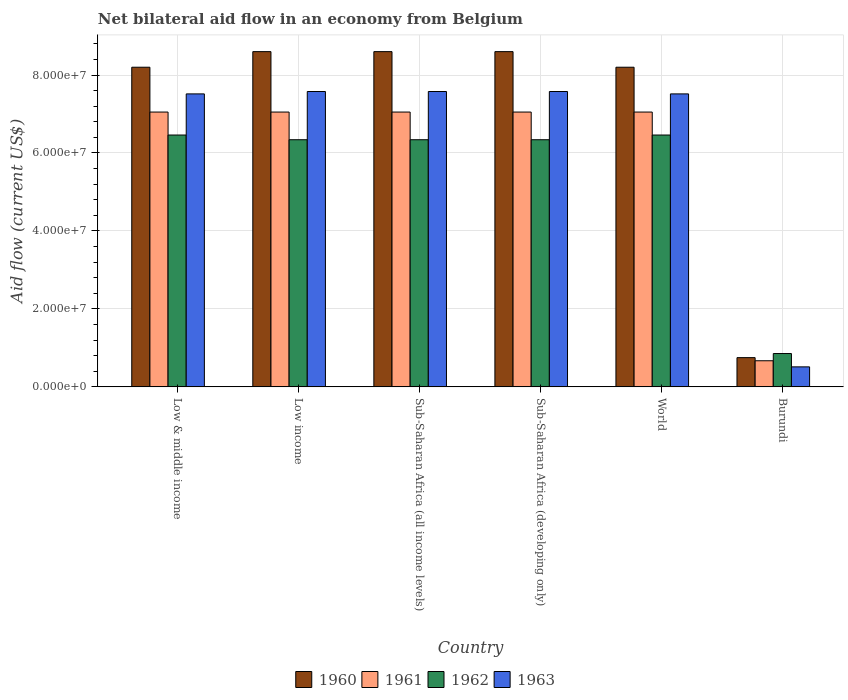How many different coloured bars are there?
Your answer should be compact. 4. Are the number of bars per tick equal to the number of legend labels?
Offer a terse response. Yes. How many bars are there on the 3rd tick from the right?
Provide a short and direct response. 4. What is the net bilateral aid flow in 1960 in Low & middle income?
Offer a terse response. 8.20e+07. Across all countries, what is the maximum net bilateral aid flow in 1963?
Your response must be concise. 7.58e+07. Across all countries, what is the minimum net bilateral aid flow in 1960?
Ensure brevity in your answer.  7.50e+06. In which country was the net bilateral aid flow in 1962 minimum?
Offer a terse response. Burundi. What is the total net bilateral aid flow in 1960 in the graph?
Offer a terse response. 4.30e+08. What is the difference between the net bilateral aid flow in 1962 in Sub-Saharan Africa (all income levels) and that in Sub-Saharan Africa (developing only)?
Provide a short and direct response. 0. What is the difference between the net bilateral aid flow in 1962 in Low & middle income and the net bilateral aid flow in 1961 in Low income?
Provide a succinct answer. -5.89e+06. What is the average net bilateral aid flow in 1960 per country?
Keep it short and to the point. 7.16e+07. What is the difference between the net bilateral aid flow of/in 1960 and net bilateral aid flow of/in 1962 in Low & middle income?
Ensure brevity in your answer.  1.74e+07. In how many countries, is the net bilateral aid flow in 1960 greater than 80000000 US$?
Provide a succinct answer. 5. What is the ratio of the net bilateral aid flow in 1962 in Burundi to that in Sub-Saharan Africa (all income levels)?
Your response must be concise. 0.13. Is the net bilateral aid flow in 1962 in Sub-Saharan Africa (all income levels) less than that in World?
Offer a very short reply. Yes. What is the difference between the highest and the second highest net bilateral aid flow in 1962?
Provide a succinct answer. 1.21e+06. What is the difference between the highest and the lowest net bilateral aid flow in 1963?
Your answer should be compact. 7.06e+07. In how many countries, is the net bilateral aid flow in 1961 greater than the average net bilateral aid flow in 1961 taken over all countries?
Your answer should be very brief. 5. Is the sum of the net bilateral aid flow in 1963 in Low income and World greater than the maximum net bilateral aid flow in 1962 across all countries?
Ensure brevity in your answer.  Yes. What does the 4th bar from the left in World represents?
Keep it short and to the point. 1963. What does the 3rd bar from the right in Burundi represents?
Your response must be concise. 1961. Is it the case that in every country, the sum of the net bilateral aid flow in 1961 and net bilateral aid flow in 1962 is greater than the net bilateral aid flow in 1960?
Provide a succinct answer. Yes. Are all the bars in the graph horizontal?
Keep it short and to the point. No. How many countries are there in the graph?
Provide a short and direct response. 6. Are the values on the major ticks of Y-axis written in scientific E-notation?
Ensure brevity in your answer.  Yes. Does the graph contain any zero values?
Your answer should be very brief. No. Does the graph contain grids?
Ensure brevity in your answer.  Yes. Where does the legend appear in the graph?
Your response must be concise. Bottom center. How are the legend labels stacked?
Keep it short and to the point. Horizontal. What is the title of the graph?
Offer a very short reply. Net bilateral aid flow in an economy from Belgium. Does "2013" appear as one of the legend labels in the graph?
Keep it short and to the point. No. What is the label or title of the X-axis?
Provide a succinct answer. Country. What is the label or title of the Y-axis?
Ensure brevity in your answer.  Aid flow (current US$). What is the Aid flow (current US$) of 1960 in Low & middle income?
Provide a short and direct response. 8.20e+07. What is the Aid flow (current US$) of 1961 in Low & middle income?
Your answer should be compact. 7.05e+07. What is the Aid flow (current US$) in 1962 in Low & middle income?
Give a very brief answer. 6.46e+07. What is the Aid flow (current US$) in 1963 in Low & middle income?
Make the answer very short. 7.52e+07. What is the Aid flow (current US$) in 1960 in Low income?
Offer a very short reply. 8.60e+07. What is the Aid flow (current US$) of 1961 in Low income?
Your answer should be compact. 7.05e+07. What is the Aid flow (current US$) in 1962 in Low income?
Your answer should be compact. 6.34e+07. What is the Aid flow (current US$) of 1963 in Low income?
Your answer should be compact. 7.58e+07. What is the Aid flow (current US$) of 1960 in Sub-Saharan Africa (all income levels)?
Provide a short and direct response. 8.60e+07. What is the Aid flow (current US$) in 1961 in Sub-Saharan Africa (all income levels)?
Keep it short and to the point. 7.05e+07. What is the Aid flow (current US$) in 1962 in Sub-Saharan Africa (all income levels)?
Your response must be concise. 6.34e+07. What is the Aid flow (current US$) of 1963 in Sub-Saharan Africa (all income levels)?
Ensure brevity in your answer.  7.58e+07. What is the Aid flow (current US$) of 1960 in Sub-Saharan Africa (developing only)?
Give a very brief answer. 8.60e+07. What is the Aid flow (current US$) in 1961 in Sub-Saharan Africa (developing only)?
Provide a short and direct response. 7.05e+07. What is the Aid flow (current US$) of 1962 in Sub-Saharan Africa (developing only)?
Offer a terse response. 6.34e+07. What is the Aid flow (current US$) of 1963 in Sub-Saharan Africa (developing only)?
Your response must be concise. 7.58e+07. What is the Aid flow (current US$) of 1960 in World?
Ensure brevity in your answer.  8.20e+07. What is the Aid flow (current US$) of 1961 in World?
Provide a short and direct response. 7.05e+07. What is the Aid flow (current US$) of 1962 in World?
Make the answer very short. 6.46e+07. What is the Aid flow (current US$) in 1963 in World?
Ensure brevity in your answer.  7.52e+07. What is the Aid flow (current US$) in 1960 in Burundi?
Keep it short and to the point. 7.50e+06. What is the Aid flow (current US$) in 1961 in Burundi?
Ensure brevity in your answer.  6.70e+06. What is the Aid flow (current US$) in 1962 in Burundi?
Provide a succinct answer. 8.55e+06. What is the Aid flow (current US$) of 1963 in Burundi?
Offer a terse response. 5.13e+06. Across all countries, what is the maximum Aid flow (current US$) of 1960?
Give a very brief answer. 8.60e+07. Across all countries, what is the maximum Aid flow (current US$) in 1961?
Your response must be concise. 7.05e+07. Across all countries, what is the maximum Aid flow (current US$) of 1962?
Give a very brief answer. 6.46e+07. Across all countries, what is the maximum Aid flow (current US$) in 1963?
Offer a very short reply. 7.58e+07. Across all countries, what is the minimum Aid flow (current US$) in 1960?
Your answer should be very brief. 7.50e+06. Across all countries, what is the minimum Aid flow (current US$) in 1961?
Provide a succinct answer. 6.70e+06. Across all countries, what is the minimum Aid flow (current US$) in 1962?
Offer a terse response. 8.55e+06. Across all countries, what is the minimum Aid flow (current US$) of 1963?
Ensure brevity in your answer.  5.13e+06. What is the total Aid flow (current US$) in 1960 in the graph?
Provide a succinct answer. 4.30e+08. What is the total Aid flow (current US$) in 1961 in the graph?
Provide a short and direct response. 3.59e+08. What is the total Aid flow (current US$) of 1962 in the graph?
Keep it short and to the point. 3.28e+08. What is the total Aid flow (current US$) of 1963 in the graph?
Keep it short and to the point. 3.83e+08. What is the difference between the Aid flow (current US$) of 1960 in Low & middle income and that in Low income?
Ensure brevity in your answer.  -4.00e+06. What is the difference between the Aid flow (current US$) in 1961 in Low & middle income and that in Low income?
Your answer should be very brief. 0. What is the difference between the Aid flow (current US$) of 1962 in Low & middle income and that in Low income?
Your response must be concise. 1.21e+06. What is the difference between the Aid flow (current US$) of 1963 in Low & middle income and that in Low income?
Your answer should be very brief. -6.10e+05. What is the difference between the Aid flow (current US$) in 1961 in Low & middle income and that in Sub-Saharan Africa (all income levels)?
Your answer should be very brief. 0. What is the difference between the Aid flow (current US$) of 1962 in Low & middle income and that in Sub-Saharan Africa (all income levels)?
Provide a short and direct response. 1.21e+06. What is the difference between the Aid flow (current US$) of 1963 in Low & middle income and that in Sub-Saharan Africa (all income levels)?
Offer a very short reply. -6.10e+05. What is the difference between the Aid flow (current US$) in 1960 in Low & middle income and that in Sub-Saharan Africa (developing only)?
Offer a terse response. -4.00e+06. What is the difference between the Aid flow (current US$) of 1962 in Low & middle income and that in Sub-Saharan Africa (developing only)?
Offer a terse response. 1.21e+06. What is the difference between the Aid flow (current US$) of 1963 in Low & middle income and that in Sub-Saharan Africa (developing only)?
Your answer should be compact. -6.10e+05. What is the difference between the Aid flow (current US$) of 1961 in Low & middle income and that in World?
Keep it short and to the point. 0. What is the difference between the Aid flow (current US$) of 1963 in Low & middle income and that in World?
Your answer should be compact. 0. What is the difference between the Aid flow (current US$) in 1960 in Low & middle income and that in Burundi?
Offer a very short reply. 7.45e+07. What is the difference between the Aid flow (current US$) of 1961 in Low & middle income and that in Burundi?
Offer a terse response. 6.38e+07. What is the difference between the Aid flow (current US$) of 1962 in Low & middle income and that in Burundi?
Your answer should be very brief. 5.61e+07. What is the difference between the Aid flow (current US$) in 1963 in Low & middle income and that in Burundi?
Give a very brief answer. 7.00e+07. What is the difference between the Aid flow (current US$) in 1960 in Low income and that in Sub-Saharan Africa (all income levels)?
Your response must be concise. 0. What is the difference between the Aid flow (current US$) in 1961 in Low income and that in Sub-Saharan Africa (all income levels)?
Your answer should be compact. 0. What is the difference between the Aid flow (current US$) in 1960 in Low income and that in Sub-Saharan Africa (developing only)?
Ensure brevity in your answer.  0. What is the difference between the Aid flow (current US$) in 1961 in Low income and that in Sub-Saharan Africa (developing only)?
Offer a terse response. 0. What is the difference between the Aid flow (current US$) in 1963 in Low income and that in Sub-Saharan Africa (developing only)?
Offer a terse response. 0. What is the difference between the Aid flow (current US$) in 1960 in Low income and that in World?
Ensure brevity in your answer.  4.00e+06. What is the difference between the Aid flow (current US$) in 1962 in Low income and that in World?
Your answer should be very brief. -1.21e+06. What is the difference between the Aid flow (current US$) in 1963 in Low income and that in World?
Your answer should be very brief. 6.10e+05. What is the difference between the Aid flow (current US$) of 1960 in Low income and that in Burundi?
Keep it short and to the point. 7.85e+07. What is the difference between the Aid flow (current US$) in 1961 in Low income and that in Burundi?
Your response must be concise. 6.38e+07. What is the difference between the Aid flow (current US$) of 1962 in Low income and that in Burundi?
Your answer should be compact. 5.48e+07. What is the difference between the Aid flow (current US$) in 1963 in Low income and that in Burundi?
Offer a terse response. 7.06e+07. What is the difference between the Aid flow (current US$) of 1963 in Sub-Saharan Africa (all income levels) and that in Sub-Saharan Africa (developing only)?
Offer a very short reply. 0. What is the difference between the Aid flow (current US$) of 1960 in Sub-Saharan Africa (all income levels) and that in World?
Your answer should be compact. 4.00e+06. What is the difference between the Aid flow (current US$) in 1961 in Sub-Saharan Africa (all income levels) and that in World?
Your response must be concise. 0. What is the difference between the Aid flow (current US$) in 1962 in Sub-Saharan Africa (all income levels) and that in World?
Provide a short and direct response. -1.21e+06. What is the difference between the Aid flow (current US$) in 1960 in Sub-Saharan Africa (all income levels) and that in Burundi?
Provide a short and direct response. 7.85e+07. What is the difference between the Aid flow (current US$) of 1961 in Sub-Saharan Africa (all income levels) and that in Burundi?
Your answer should be very brief. 6.38e+07. What is the difference between the Aid flow (current US$) of 1962 in Sub-Saharan Africa (all income levels) and that in Burundi?
Keep it short and to the point. 5.48e+07. What is the difference between the Aid flow (current US$) in 1963 in Sub-Saharan Africa (all income levels) and that in Burundi?
Provide a succinct answer. 7.06e+07. What is the difference between the Aid flow (current US$) in 1962 in Sub-Saharan Africa (developing only) and that in World?
Your answer should be compact. -1.21e+06. What is the difference between the Aid flow (current US$) in 1960 in Sub-Saharan Africa (developing only) and that in Burundi?
Your answer should be compact. 7.85e+07. What is the difference between the Aid flow (current US$) of 1961 in Sub-Saharan Africa (developing only) and that in Burundi?
Offer a terse response. 6.38e+07. What is the difference between the Aid flow (current US$) in 1962 in Sub-Saharan Africa (developing only) and that in Burundi?
Offer a very short reply. 5.48e+07. What is the difference between the Aid flow (current US$) of 1963 in Sub-Saharan Africa (developing only) and that in Burundi?
Offer a very short reply. 7.06e+07. What is the difference between the Aid flow (current US$) in 1960 in World and that in Burundi?
Ensure brevity in your answer.  7.45e+07. What is the difference between the Aid flow (current US$) of 1961 in World and that in Burundi?
Give a very brief answer. 6.38e+07. What is the difference between the Aid flow (current US$) in 1962 in World and that in Burundi?
Provide a succinct answer. 5.61e+07. What is the difference between the Aid flow (current US$) of 1963 in World and that in Burundi?
Provide a short and direct response. 7.00e+07. What is the difference between the Aid flow (current US$) in 1960 in Low & middle income and the Aid flow (current US$) in 1961 in Low income?
Give a very brief answer. 1.15e+07. What is the difference between the Aid flow (current US$) in 1960 in Low & middle income and the Aid flow (current US$) in 1962 in Low income?
Offer a terse response. 1.86e+07. What is the difference between the Aid flow (current US$) in 1960 in Low & middle income and the Aid flow (current US$) in 1963 in Low income?
Your response must be concise. 6.23e+06. What is the difference between the Aid flow (current US$) in 1961 in Low & middle income and the Aid flow (current US$) in 1962 in Low income?
Your answer should be compact. 7.10e+06. What is the difference between the Aid flow (current US$) in 1961 in Low & middle income and the Aid flow (current US$) in 1963 in Low income?
Provide a succinct answer. -5.27e+06. What is the difference between the Aid flow (current US$) of 1962 in Low & middle income and the Aid flow (current US$) of 1963 in Low income?
Provide a succinct answer. -1.12e+07. What is the difference between the Aid flow (current US$) in 1960 in Low & middle income and the Aid flow (current US$) in 1961 in Sub-Saharan Africa (all income levels)?
Ensure brevity in your answer.  1.15e+07. What is the difference between the Aid flow (current US$) in 1960 in Low & middle income and the Aid flow (current US$) in 1962 in Sub-Saharan Africa (all income levels)?
Offer a terse response. 1.86e+07. What is the difference between the Aid flow (current US$) in 1960 in Low & middle income and the Aid flow (current US$) in 1963 in Sub-Saharan Africa (all income levels)?
Keep it short and to the point. 6.23e+06. What is the difference between the Aid flow (current US$) of 1961 in Low & middle income and the Aid flow (current US$) of 1962 in Sub-Saharan Africa (all income levels)?
Provide a short and direct response. 7.10e+06. What is the difference between the Aid flow (current US$) of 1961 in Low & middle income and the Aid flow (current US$) of 1963 in Sub-Saharan Africa (all income levels)?
Offer a very short reply. -5.27e+06. What is the difference between the Aid flow (current US$) of 1962 in Low & middle income and the Aid flow (current US$) of 1963 in Sub-Saharan Africa (all income levels)?
Your response must be concise. -1.12e+07. What is the difference between the Aid flow (current US$) in 1960 in Low & middle income and the Aid flow (current US$) in 1961 in Sub-Saharan Africa (developing only)?
Your answer should be compact. 1.15e+07. What is the difference between the Aid flow (current US$) of 1960 in Low & middle income and the Aid flow (current US$) of 1962 in Sub-Saharan Africa (developing only)?
Ensure brevity in your answer.  1.86e+07. What is the difference between the Aid flow (current US$) in 1960 in Low & middle income and the Aid flow (current US$) in 1963 in Sub-Saharan Africa (developing only)?
Make the answer very short. 6.23e+06. What is the difference between the Aid flow (current US$) in 1961 in Low & middle income and the Aid flow (current US$) in 1962 in Sub-Saharan Africa (developing only)?
Make the answer very short. 7.10e+06. What is the difference between the Aid flow (current US$) in 1961 in Low & middle income and the Aid flow (current US$) in 1963 in Sub-Saharan Africa (developing only)?
Keep it short and to the point. -5.27e+06. What is the difference between the Aid flow (current US$) in 1962 in Low & middle income and the Aid flow (current US$) in 1963 in Sub-Saharan Africa (developing only)?
Your answer should be very brief. -1.12e+07. What is the difference between the Aid flow (current US$) in 1960 in Low & middle income and the Aid flow (current US$) in 1961 in World?
Keep it short and to the point. 1.15e+07. What is the difference between the Aid flow (current US$) in 1960 in Low & middle income and the Aid flow (current US$) in 1962 in World?
Your answer should be compact. 1.74e+07. What is the difference between the Aid flow (current US$) of 1960 in Low & middle income and the Aid flow (current US$) of 1963 in World?
Give a very brief answer. 6.84e+06. What is the difference between the Aid flow (current US$) in 1961 in Low & middle income and the Aid flow (current US$) in 1962 in World?
Your answer should be compact. 5.89e+06. What is the difference between the Aid flow (current US$) in 1961 in Low & middle income and the Aid flow (current US$) in 1963 in World?
Your answer should be very brief. -4.66e+06. What is the difference between the Aid flow (current US$) of 1962 in Low & middle income and the Aid flow (current US$) of 1963 in World?
Provide a short and direct response. -1.06e+07. What is the difference between the Aid flow (current US$) of 1960 in Low & middle income and the Aid flow (current US$) of 1961 in Burundi?
Offer a very short reply. 7.53e+07. What is the difference between the Aid flow (current US$) in 1960 in Low & middle income and the Aid flow (current US$) in 1962 in Burundi?
Your answer should be compact. 7.34e+07. What is the difference between the Aid flow (current US$) of 1960 in Low & middle income and the Aid flow (current US$) of 1963 in Burundi?
Offer a very short reply. 7.69e+07. What is the difference between the Aid flow (current US$) in 1961 in Low & middle income and the Aid flow (current US$) in 1962 in Burundi?
Keep it short and to the point. 6.20e+07. What is the difference between the Aid flow (current US$) in 1961 in Low & middle income and the Aid flow (current US$) in 1963 in Burundi?
Your response must be concise. 6.54e+07. What is the difference between the Aid flow (current US$) in 1962 in Low & middle income and the Aid flow (current US$) in 1963 in Burundi?
Your answer should be compact. 5.95e+07. What is the difference between the Aid flow (current US$) in 1960 in Low income and the Aid flow (current US$) in 1961 in Sub-Saharan Africa (all income levels)?
Offer a terse response. 1.55e+07. What is the difference between the Aid flow (current US$) in 1960 in Low income and the Aid flow (current US$) in 1962 in Sub-Saharan Africa (all income levels)?
Your answer should be compact. 2.26e+07. What is the difference between the Aid flow (current US$) of 1960 in Low income and the Aid flow (current US$) of 1963 in Sub-Saharan Africa (all income levels)?
Offer a terse response. 1.02e+07. What is the difference between the Aid flow (current US$) in 1961 in Low income and the Aid flow (current US$) in 1962 in Sub-Saharan Africa (all income levels)?
Make the answer very short. 7.10e+06. What is the difference between the Aid flow (current US$) of 1961 in Low income and the Aid flow (current US$) of 1963 in Sub-Saharan Africa (all income levels)?
Your response must be concise. -5.27e+06. What is the difference between the Aid flow (current US$) of 1962 in Low income and the Aid flow (current US$) of 1963 in Sub-Saharan Africa (all income levels)?
Your answer should be compact. -1.24e+07. What is the difference between the Aid flow (current US$) in 1960 in Low income and the Aid flow (current US$) in 1961 in Sub-Saharan Africa (developing only)?
Offer a terse response. 1.55e+07. What is the difference between the Aid flow (current US$) of 1960 in Low income and the Aid flow (current US$) of 1962 in Sub-Saharan Africa (developing only)?
Ensure brevity in your answer.  2.26e+07. What is the difference between the Aid flow (current US$) of 1960 in Low income and the Aid flow (current US$) of 1963 in Sub-Saharan Africa (developing only)?
Your response must be concise. 1.02e+07. What is the difference between the Aid flow (current US$) of 1961 in Low income and the Aid flow (current US$) of 1962 in Sub-Saharan Africa (developing only)?
Keep it short and to the point. 7.10e+06. What is the difference between the Aid flow (current US$) in 1961 in Low income and the Aid flow (current US$) in 1963 in Sub-Saharan Africa (developing only)?
Make the answer very short. -5.27e+06. What is the difference between the Aid flow (current US$) of 1962 in Low income and the Aid flow (current US$) of 1963 in Sub-Saharan Africa (developing only)?
Provide a succinct answer. -1.24e+07. What is the difference between the Aid flow (current US$) in 1960 in Low income and the Aid flow (current US$) in 1961 in World?
Ensure brevity in your answer.  1.55e+07. What is the difference between the Aid flow (current US$) of 1960 in Low income and the Aid flow (current US$) of 1962 in World?
Ensure brevity in your answer.  2.14e+07. What is the difference between the Aid flow (current US$) in 1960 in Low income and the Aid flow (current US$) in 1963 in World?
Offer a terse response. 1.08e+07. What is the difference between the Aid flow (current US$) in 1961 in Low income and the Aid flow (current US$) in 1962 in World?
Make the answer very short. 5.89e+06. What is the difference between the Aid flow (current US$) of 1961 in Low income and the Aid flow (current US$) of 1963 in World?
Keep it short and to the point. -4.66e+06. What is the difference between the Aid flow (current US$) in 1962 in Low income and the Aid flow (current US$) in 1963 in World?
Provide a succinct answer. -1.18e+07. What is the difference between the Aid flow (current US$) of 1960 in Low income and the Aid flow (current US$) of 1961 in Burundi?
Offer a very short reply. 7.93e+07. What is the difference between the Aid flow (current US$) of 1960 in Low income and the Aid flow (current US$) of 1962 in Burundi?
Make the answer very short. 7.74e+07. What is the difference between the Aid flow (current US$) of 1960 in Low income and the Aid flow (current US$) of 1963 in Burundi?
Provide a short and direct response. 8.09e+07. What is the difference between the Aid flow (current US$) of 1961 in Low income and the Aid flow (current US$) of 1962 in Burundi?
Make the answer very short. 6.20e+07. What is the difference between the Aid flow (current US$) in 1961 in Low income and the Aid flow (current US$) in 1963 in Burundi?
Give a very brief answer. 6.54e+07. What is the difference between the Aid flow (current US$) in 1962 in Low income and the Aid flow (current US$) in 1963 in Burundi?
Give a very brief answer. 5.83e+07. What is the difference between the Aid flow (current US$) in 1960 in Sub-Saharan Africa (all income levels) and the Aid flow (current US$) in 1961 in Sub-Saharan Africa (developing only)?
Provide a succinct answer. 1.55e+07. What is the difference between the Aid flow (current US$) in 1960 in Sub-Saharan Africa (all income levels) and the Aid flow (current US$) in 1962 in Sub-Saharan Africa (developing only)?
Your answer should be compact. 2.26e+07. What is the difference between the Aid flow (current US$) of 1960 in Sub-Saharan Africa (all income levels) and the Aid flow (current US$) of 1963 in Sub-Saharan Africa (developing only)?
Offer a very short reply. 1.02e+07. What is the difference between the Aid flow (current US$) of 1961 in Sub-Saharan Africa (all income levels) and the Aid flow (current US$) of 1962 in Sub-Saharan Africa (developing only)?
Give a very brief answer. 7.10e+06. What is the difference between the Aid flow (current US$) in 1961 in Sub-Saharan Africa (all income levels) and the Aid flow (current US$) in 1963 in Sub-Saharan Africa (developing only)?
Provide a short and direct response. -5.27e+06. What is the difference between the Aid flow (current US$) of 1962 in Sub-Saharan Africa (all income levels) and the Aid flow (current US$) of 1963 in Sub-Saharan Africa (developing only)?
Give a very brief answer. -1.24e+07. What is the difference between the Aid flow (current US$) in 1960 in Sub-Saharan Africa (all income levels) and the Aid flow (current US$) in 1961 in World?
Your answer should be very brief. 1.55e+07. What is the difference between the Aid flow (current US$) in 1960 in Sub-Saharan Africa (all income levels) and the Aid flow (current US$) in 1962 in World?
Provide a succinct answer. 2.14e+07. What is the difference between the Aid flow (current US$) of 1960 in Sub-Saharan Africa (all income levels) and the Aid flow (current US$) of 1963 in World?
Offer a terse response. 1.08e+07. What is the difference between the Aid flow (current US$) of 1961 in Sub-Saharan Africa (all income levels) and the Aid flow (current US$) of 1962 in World?
Make the answer very short. 5.89e+06. What is the difference between the Aid flow (current US$) of 1961 in Sub-Saharan Africa (all income levels) and the Aid flow (current US$) of 1963 in World?
Provide a short and direct response. -4.66e+06. What is the difference between the Aid flow (current US$) in 1962 in Sub-Saharan Africa (all income levels) and the Aid flow (current US$) in 1963 in World?
Your answer should be very brief. -1.18e+07. What is the difference between the Aid flow (current US$) in 1960 in Sub-Saharan Africa (all income levels) and the Aid flow (current US$) in 1961 in Burundi?
Give a very brief answer. 7.93e+07. What is the difference between the Aid flow (current US$) of 1960 in Sub-Saharan Africa (all income levels) and the Aid flow (current US$) of 1962 in Burundi?
Give a very brief answer. 7.74e+07. What is the difference between the Aid flow (current US$) of 1960 in Sub-Saharan Africa (all income levels) and the Aid flow (current US$) of 1963 in Burundi?
Keep it short and to the point. 8.09e+07. What is the difference between the Aid flow (current US$) in 1961 in Sub-Saharan Africa (all income levels) and the Aid flow (current US$) in 1962 in Burundi?
Make the answer very short. 6.20e+07. What is the difference between the Aid flow (current US$) in 1961 in Sub-Saharan Africa (all income levels) and the Aid flow (current US$) in 1963 in Burundi?
Ensure brevity in your answer.  6.54e+07. What is the difference between the Aid flow (current US$) in 1962 in Sub-Saharan Africa (all income levels) and the Aid flow (current US$) in 1963 in Burundi?
Offer a very short reply. 5.83e+07. What is the difference between the Aid flow (current US$) of 1960 in Sub-Saharan Africa (developing only) and the Aid flow (current US$) of 1961 in World?
Keep it short and to the point. 1.55e+07. What is the difference between the Aid flow (current US$) of 1960 in Sub-Saharan Africa (developing only) and the Aid flow (current US$) of 1962 in World?
Ensure brevity in your answer.  2.14e+07. What is the difference between the Aid flow (current US$) of 1960 in Sub-Saharan Africa (developing only) and the Aid flow (current US$) of 1963 in World?
Provide a succinct answer. 1.08e+07. What is the difference between the Aid flow (current US$) in 1961 in Sub-Saharan Africa (developing only) and the Aid flow (current US$) in 1962 in World?
Give a very brief answer. 5.89e+06. What is the difference between the Aid flow (current US$) of 1961 in Sub-Saharan Africa (developing only) and the Aid flow (current US$) of 1963 in World?
Make the answer very short. -4.66e+06. What is the difference between the Aid flow (current US$) of 1962 in Sub-Saharan Africa (developing only) and the Aid flow (current US$) of 1963 in World?
Offer a terse response. -1.18e+07. What is the difference between the Aid flow (current US$) in 1960 in Sub-Saharan Africa (developing only) and the Aid flow (current US$) in 1961 in Burundi?
Your answer should be compact. 7.93e+07. What is the difference between the Aid flow (current US$) of 1960 in Sub-Saharan Africa (developing only) and the Aid flow (current US$) of 1962 in Burundi?
Your response must be concise. 7.74e+07. What is the difference between the Aid flow (current US$) in 1960 in Sub-Saharan Africa (developing only) and the Aid flow (current US$) in 1963 in Burundi?
Your answer should be compact. 8.09e+07. What is the difference between the Aid flow (current US$) in 1961 in Sub-Saharan Africa (developing only) and the Aid flow (current US$) in 1962 in Burundi?
Ensure brevity in your answer.  6.20e+07. What is the difference between the Aid flow (current US$) of 1961 in Sub-Saharan Africa (developing only) and the Aid flow (current US$) of 1963 in Burundi?
Provide a succinct answer. 6.54e+07. What is the difference between the Aid flow (current US$) in 1962 in Sub-Saharan Africa (developing only) and the Aid flow (current US$) in 1963 in Burundi?
Give a very brief answer. 5.83e+07. What is the difference between the Aid flow (current US$) of 1960 in World and the Aid flow (current US$) of 1961 in Burundi?
Your answer should be very brief. 7.53e+07. What is the difference between the Aid flow (current US$) in 1960 in World and the Aid flow (current US$) in 1962 in Burundi?
Give a very brief answer. 7.34e+07. What is the difference between the Aid flow (current US$) of 1960 in World and the Aid flow (current US$) of 1963 in Burundi?
Ensure brevity in your answer.  7.69e+07. What is the difference between the Aid flow (current US$) in 1961 in World and the Aid flow (current US$) in 1962 in Burundi?
Your answer should be very brief. 6.20e+07. What is the difference between the Aid flow (current US$) of 1961 in World and the Aid flow (current US$) of 1963 in Burundi?
Provide a short and direct response. 6.54e+07. What is the difference between the Aid flow (current US$) of 1962 in World and the Aid flow (current US$) of 1963 in Burundi?
Make the answer very short. 5.95e+07. What is the average Aid flow (current US$) in 1960 per country?
Your answer should be compact. 7.16e+07. What is the average Aid flow (current US$) in 1961 per country?
Your answer should be very brief. 5.99e+07. What is the average Aid flow (current US$) of 1962 per country?
Provide a succinct answer. 5.47e+07. What is the average Aid flow (current US$) in 1963 per country?
Your answer should be compact. 6.38e+07. What is the difference between the Aid flow (current US$) in 1960 and Aid flow (current US$) in 1961 in Low & middle income?
Give a very brief answer. 1.15e+07. What is the difference between the Aid flow (current US$) of 1960 and Aid flow (current US$) of 1962 in Low & middle income?
Offer a terse response. 1.74e+07. What is the difference between the Aid flow (current US$) in 1960 and Aid flow (current US$) in 1963 in Low & middle income?
Give a very brief answer. 6.84e+06. What is the difference between the Aid flow (current US$) in 1961 and Aid flow (current US$) in 1962 in Low & middle income?
Provide a short and direct response. 5.89e+06. What is the difference between the Aid flow (current US$) in 1961 and Aid flow (current US$) in 1963 in Low & middle income?
Your answer should be compact. -4.66e+06. What is the difference between the Aid flow (current US$) of 1962 and Aid flow (current US$) of 1963 in Low & middle income?
Your response must be concise. -1.06e+07. What is the difference between the Aid flow (current US$) in 1960 and Aid flow (current US$) in 1961 in Low income?
Keep it short and to the point. 1.55e+07. What is the difference between the Aid flow (current US$) in 1960 and Aid flow (current US$) in 1962 in Low income?
Give a very brief answer. 2.26e+07. What is the difference between the Aid flow (current US$) of 1960 and Aid flow (current US$) of 1963 in Low income?
Your response must be concise. 1.02e+07. What is the difference between the Aid flow (current US$) of 1961 and Aid flow (current US$) of 1962 in Low income?
Ensure brevity in your answer.  7.10e+06. What is the difference between the Aid flow (current US$) in 1961 and Aid flow (current US$) in 1963 in Low income?
Keep it short and to the point. -5.27e+06. What is the difference between the Aid flow (current US$) in 1962 and Aid flow (current US$) in 1963 in Low income?
Your answer should be compact. -1.24e+07. What is the difference between the Aid flow (current US$) in 1960 and Aid flow (current US$) in 1961 in Sub-Saharan Africa (all income levels)?
Keep it short and to the point. 1.55e+07. What is the difference between the Aid flow (current US$) in 1960 and Aid flow (current US$) in 1962 in Sub-Saharan Africa (all income levels)?
Offer a terse response. 2.26e+07. What is the difference between the Aid flow (current US$) of 1960 and Aid flow (current US$) of 1963 in Sub-Saharan Africa (all income levels)?
Provide a succinct answer. 1.02e+07. What is the difference between the Aid flow (current US$) in 1961 and Aid flow (current US$) in 1962 in Sub-Saharan Africa (all income levels)?
Make the answer very short. 7.10e+06. What is the difference between the Aid flow (current US$) of 1961 and Aid flow (current US$) of 1963 in Sub-Saharan Africa (all income levels)?
Give a very brief answer. -5.27e+06. What is the difference between the Aid flow (current US$) of 1962 and Aid flow (current US$) of 1963 in Sub-Saharan Africa (all income levels)?
Keep it short and to the point. -1.24e+07. What is the difference between the Aid flow (current US$) of 1960 and Aid flow (current US$) of 1961 in Sub-Saharan Africa (developing only)?
Ensure brevity in your answer.  1.55e+07. What is the difference between the Aid flow (current US$) of 1960 and Aid flow (current US$) of 1962 in Sub-Saharan Africa (developing only)?
Offer a very short reply. 2.26e+07. What is the difference between the Aid flow (current US$) of 1960 and Aid flow (current US$) of 1963 in Sub-Saharan Africa (developing only)?
Your answer should be very brief. 1.02e+07. What is the difference between the Aid flow (current US$) of 1961 and Aid flow (current US$) of 1962 in Sub-Saharan Africa (developing only)?
Ensure brevity in your answer.  7.10e+06. What is the difference between the Aid flow (current US$) of 1961 and Aid flow (current US$) of 1963 in Sub-Saharan Africa (developing only)?
Your answer should be compact. -5.27e+06. What is the difference between the Aid flow (current US$) in 1962 and Aid flow (current US$) in 1963 in Sub-Saharan Africa (developing only)?
Give a very brief answer. -1.24e+07. What is the difference between the Aid flow (current US$) in 1960 and Aid flow (current US$) in 1961 in World?
Keep it short and to the point. 1.15e+07. What is the difference between the Aid flow (current US$) of 1960 and Aid flow (current US$) of 1962 in World?
Your response must be concise. 1.74e+07. What is the difference between the Aid flow (current US$) in 1960 and Aid flow (current US$) in 1963 in World?
Your answer should be very brief. 6.84e+06. What is the difference between the Aid flow (current US$) in 1961 and Aid flow (current US$) in 1962 in World?
Offer a very short reply. 5.89e+06. What is the difference between the Aid flow (current US$) in 1961 and Aid flow (current US$) in 1963 in World?
Ensure brevity in your answer.  -4.66e+06. What is the difference between the Aid flow (current US$) in 1962 and Aid flow (current US$) in 1963 in World?
Give a very brief answer. -1.06e+07. What is the difference between the Aid flow (current US$) of 1960 and Aid flow (current US$) of 1961 in Burundi?
Give a very brief answer. 8.00e+05. What is the difference between the Aid flow (current US$) in 1960 and Aid flow (current US$) in 1962 in Burundi?
Provide a short and direct response. -1.05e+06. What is the difference between the Aid flow (current US$) in 1960 and Aid flow (current US$) in 1963 in Burundi?
Offer a very short reply. 2.37e+06. What is the difference between the Aid flow (current US$) in 1961 and Aid flow (current US$) in 1962 in Burundi?
Your answer should be very brief. -1.85e+06. What is the difference between the Aid flow (current US$) in 1961 and Aid flow (current US$) in 1963 in Burundi?
Your response must be concise. 1.57e+06. What is the difference between the Aid flow (current US$) in 1962 and Aid flow (current US$) in 1963 in Burundi?
Make the answer very short. 3.42e+06. What is the ratio of the Aid flow (current US$) of 1960 in Low & middle income to that in Low income?
Ensure brevity in your answer.  0.95. What is the ratio of the Aid flow (current US$) of 1962 in Low & middle income to that in Low income?
Your answer should be compact. 1.02. What is the ratio of the Aid flow (current US$) of 1960 in Low & middle income to that in Sub-Saharan Africa (all income levels)?
Your answer should be very brief. 0.95. What is the ratio of the Aid flow (current US$) in 1961 in Low & middle income to that in Sub-Saharan Africa (all income levels)?
Keep it short and to the point. 1. What is the ratio of the Aid flow (current US$) in 1962 in Low & middle income to that in Sub-Saharan Africa (all income levels)?
Provide a succinct answer. 1.02. What is the ratio of the Aid flow (current US$) of 1963 in Low & middle income to that in Sub-Saharan Africa (all income levels)?
Your response must be concise. 0.99. What is the ratio of the Aid flow (current US$) of 1960 in Low & middle income to that in Sub-Saharan Africa (developing only)?
Keep it short and to the point. 0.95. What is the ratio of the Aid flow (current US$) of 1961 in Low & middle income to that in Sub-Saharan Africa (developing only)?
Provide a succinct answer. 1. What is the ratio of the Aid flow (current US$) of 1962 in Low & middle income to that in Sub-Saharan Africa (developing only)?
Your response must be concise. 1.02. What is the ratio of the Aid flow (current US$) in 1963 in Low & middle income to that in Sub-Saharan Africa (developing only)?
Your response must be concise. 0.99. What is the ratio of the Aid flow (current US$) in 1960 in Low & middle income to that in World?
Give a very brief answer. 1. What is the ratio of the Aid flow (current US$) of 1960 in Low & middle income to that in Burundi?
Ensure brevity in your answer.  10.93. What is the ratio of the Aid flow (current US$) of 1961 in Low & middle income to that in Burundi?
Ensure brevity in your answer.  10.52. What is the ratio of the Aid flow (current US$) in 1962 in Low & middle income to that in Burundi?
Keep it short and to the point. 7.56. What is the ratio of the Aid flow (current US$) in 1963 in Low & middle income to that in Burundi?
Your response must be concise. 14.65. What is the ratio of the Aid flow (current US$) of 1963 in Low income to that in Sub-Saharan Africa (all income levels)?
Offer a very short reply. 1. What is the ratio of the Aid flow (current US$) in 1960 in Low income to that in Sub-Saharan Africa (developing only)?
Your answer should be compact. 1. What is the ratio of the Aid flow (current US$) in 1960 in Low income to that in World?
Provide a succinct answer. 1.05. What is the ratio of the Aid flow (current US$) in 1961 in Low income to that in World?
Make the answer very short. 1. What is the ratio of the Aid flow (current US$) in 1962 in Low income to that in World?
Give a very brief answer. 0.98. What is the ratio of the Aid flow (current US$) of 1963 in Low income to that in World?
Your answer should be very brief. 1.01. What is the ratio of the Aid flow (current US$) in 1960 in Low income to that in Burundi?
Offer a very short reply. 11.47. What is the ratio of the Aid flow (current US$) in 1961 in Low income to that in Burundi?
Offer a terse response. 10.52. What is the ratio of the Aid flow (current US$) of 1962 in Low income to that in Burundi?
Make the answer very short. 7.42. What is the ratio of the Aid flow (current US$) of 1963 in Low income to that in Burundi?
Provide a short and direct response. 14.77. What is the ratio of the Aid flow (current US$) of 1960 in Sub-Saharan Africa (all income levels) to that in Sub-Saharan Africa (developing only)?
Make the answer very short. 1. What is the ratio of the Aid flow (current US$) of 1961 in Sub-Saharan Africa (all income levels) to that in Sub-Saharan Africa (developing only)?
Ensure brevity in your answer.  1. What is the ratio of the Aid flow (current US$) in 1962 in Sub-Saharan Africa (all income levels) to that in Sub-Saharan Africa (developing only)?
Your response must be concise. 1. What is the ratio of the Aid flow (current US$) in 1960 in Sub-Saharan Africa (all income levels) to that in World?
Give a very brief answer. 1.05. What is the ratio of the Aid flow (current US$) in 1962 in Sub-Saharan Africa (all income levels) to that in World?
Provide a short and direct response. 0.98. What is the ratio of the Aid flow (current US$) in 1960 in Sub-Saharan Africa (all income levels) to that in Burundi?
Make the answer very short. 11.47. What is the ratio of the Aid flow (current US$) of 1961 in Sub-Saharan Africa (all income levels) to that in Burundi?
Your answer should be compact. 10.52. What is the ratio of the Aid flow (current US$) in 1962 in Sub-Saharan Africa (all income levels) to that in Burundi?
Keep it short and to the point. 7.42. What is the ratio of the Aid flow (current US$) of 1963 in Sub-Saharan Africa (all income levels) to that in Burundi?
Provide a short and direct response. 14.77. What is the ratio of the Aid flow (current US$) of 1960 in Sub-Saharan Africa (developing only) to that in World?
Your answer should be very brief. 1.05. What is the ratio of the Aid flow (current US$) in 1962 in Sub-Saharan Africa (developing only) to that in World?
Make the answer very short. 0.98. What is the ratio of the Aid flow (current US$) of 1960 in Sub-Saharan Africa (developing only) to that in Burundi?
Your answer should be very brief. 11.47. What is the ratio of the Aid flow (current US$) in 1961 in Sub-Saharan Africa (developing only) to that in Burundi?
Provide a short and direct response. 10.52. What is the ratio of the Aid flow (current US$) in 1962 in Sub-Saharan Africa (developing only) to that in Burundi?
Offer a terse response. 7.42. What is the ratio of the Aid flow (current US$) of 1963 in Sub-Saharan Africa (developing only) to that in Burundi?
Your answer should be very brief. 14.77. What is the ratio of the Aid flow (current US$) of 1960 in World to that in Burundi?
Offer a very short reply. 10.93. What is the ratio of the Aid flow (current US$) of 1961 in World to that in Burundi?
Offer a very short reply. 10.52. What is the ratio of the Aid flow (current US$) in 1962 in World to that in Burundi?
Keep it short and to the point. 7.56. What is the ratio of the Aid flow (current US$) in 1963 in World to that in Burundi?
Your answer should be very brief. 14.65. What is the difference between the highest and the second highest Aid flow (current US$) of 1960?
Offer a very short reply. 0. What is the difference between the highest and the second highest Aid flow (current US$) of 1961?
Offer a very short reply. 0. What is the difference between the highest and the lowest Aid flow (current US$) in 1960?
Your answer should be compact. 7.85e+07. What is the difference between the highest and the lowest Aid flow (current US$) of 1961?
Ensure brevity in your answer.  6.38e+07. What is the difference between the highest and the lowest Aid flow (current US$) in 1962?
Offer a very short reply. 5.61e+07. What is the difference between the highest and the lowest Aid flow (current US$) in 1963?
Make the answer very short. 7.06e+07. 